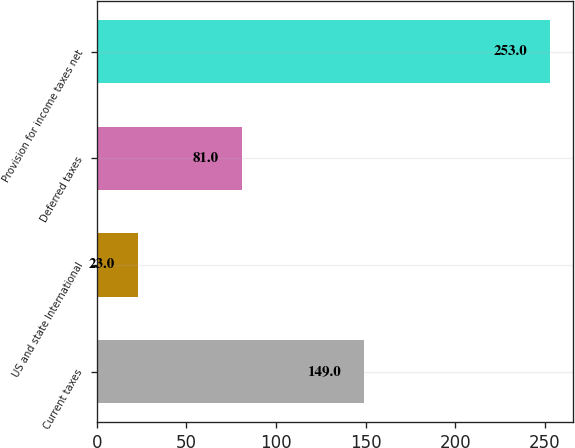<chart> <loc_0><loc_0><loc_500><loc_500><bar_chart><fcel>Current taxes<fcel>US and state International<fcel>Deferred taxes<fcel>Provision for income taxes net<nl><fcel>149<fcel>23<fcel>81<fcel>253<nl></chart> 